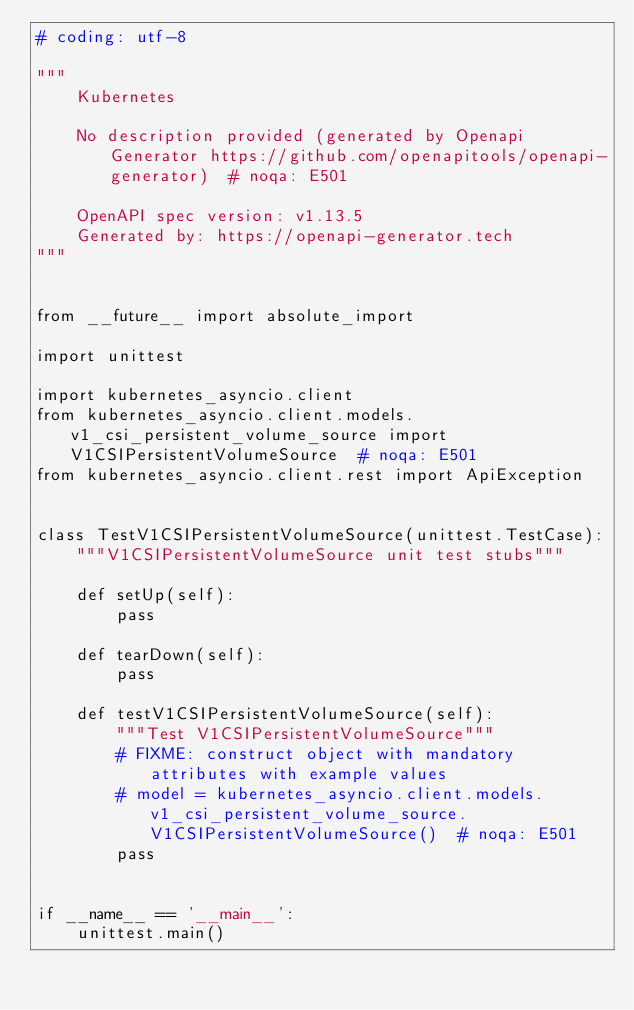Convert code to text. <code><loc_0><loc_0><loc_500><loc_500><_Python_># coding: utf-8

"""
    Kubernetes

    No description provided (generated by Openapi Generator https://github.com/openapitools/openapi-generator)  # noqa: E501

    OpenAPI spec version: v1.13.5
    Generated by: https://openapi-generator.tech
"""


from __future__ import absolute_import

import unittest

import kubernetes_asyncio.client
from kubernetes_asyncio.client.models.v1_csi_persistent_volume_source import V1CSIPersistentVolumeSource  # noqa: E501
from kubernetes_asyncio.client.rest import ApiException


class TestV1CSIPersistentVolumeSource(unittest.TestCase):
    """V1CSIPersistentVolumeSource unit test stubs"""

    def setUp(self):
        pass

    def tearDown(self):
        pass

    def testV1CSIPersistentVolumeSource(self):
        """Test V1CSIPersistentVolumeSource"""
        # FIXME: construct object with mandatory attributes with example values
        # model = kubernetes_asyncio.client.models.v1_csi_persistent_volume_source.V1CSIPersistentVolumeSource()  # noqa: E501
        pass


if __name__ == '__main__':
    unittest.main()
</code> 